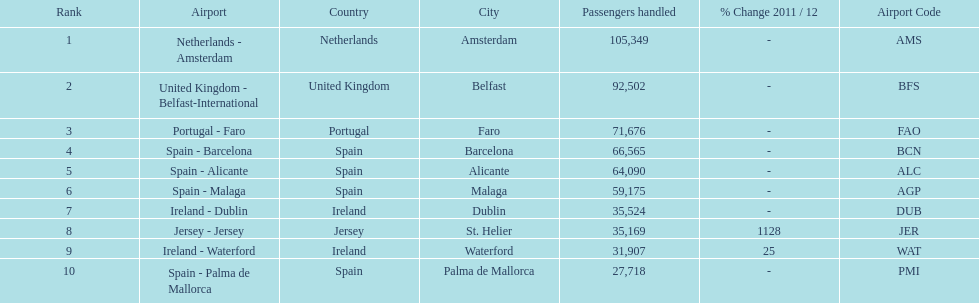Which airport had more passengers handled than the united kingdom? Netherlands - Amsterdam. 